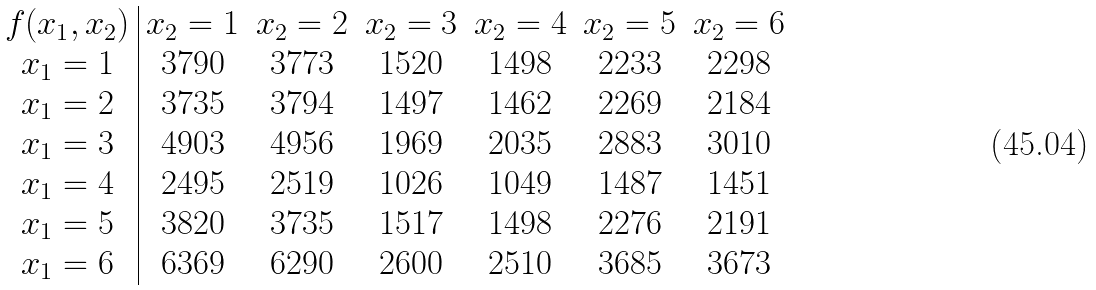<formula> <loc_0><loc_0><loc_500><loc_500>\begin{array} { c | c c c c c c } f ( x _ { 1 } , x _ { 2 } ) & x _ { 2 } = 1 & x _ { 2 } = 2 & x _ { 2 } = 3 & x _ { 2 } = 4 & x _ { 2 } = 5 & x _ { 2 } = 6 \\ x _ { 1 } = 1 & 3 7 9 0 & 3 7 7 3 & 1 5 2 0 & 1 4 9 8 & 2 2 3 3 & 2 2 9 8 \\ x _ { 1 } = 2 & 3 7 3 5 & 3 7 9 4 & 1 4 9 7 & 1 4 6 2 & 2 2 6 9 & 2 1 8 4 \\ x _ { 1 } = 3 & 4 9 0 3 & 4 9 5 6 & 1 9 6 9 & 2 0 3 5 & 2 8 8 3 & 3 0 1 0 \\ x _ { 1 } = 4 & 2 4 9 5 & 2 5 1 9 & 1 0 2 6 & 1 0 4 9 & 1 4 8 7 & 1 4 5 1 \\ x _ { 1 } = 5 & 3 8 2 0 & 3 7 3 5 & 1 5 1 7 & 1 4 9 8 & 2 2 7 6 & 2 1 9 1 \\ x _ { 1 } = 6 & 6 3 6 9 & 6 2 9 0 & 2 6 0 0 & 2 5 1 0 & 3 6 8 5 & 3 6 7 3 \end{array}</formula> 